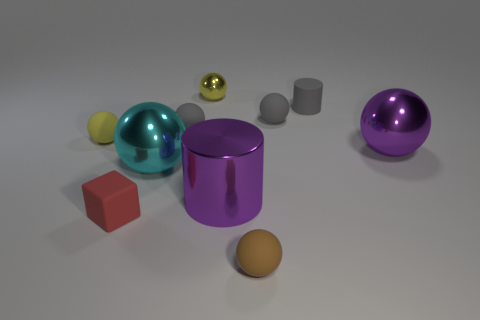Subtract all gray rubber balls. How many balls are left? 5 Subtract all cylinders. How many objects are left? 8 Subtract all gray cylinders. How many cylinders are left? 1 Add 5 yellow balls. How many yellow balls are left? 7 Add 7 large purple balls. How many large purple balls exist? 8 Subtract 1 purple cylinders. How many objects are left? 9 Subtract 2 spheres. How many spheres are left? 5 Subtract all cyan cubes. Subtract all blue spheres. How many cubes are left? 1 Subtract all brown blocks. How many gray cylinders are left? 1 Subtract all large purple shiny objects. Subtract all small matte balls. How many objects are left? 4 